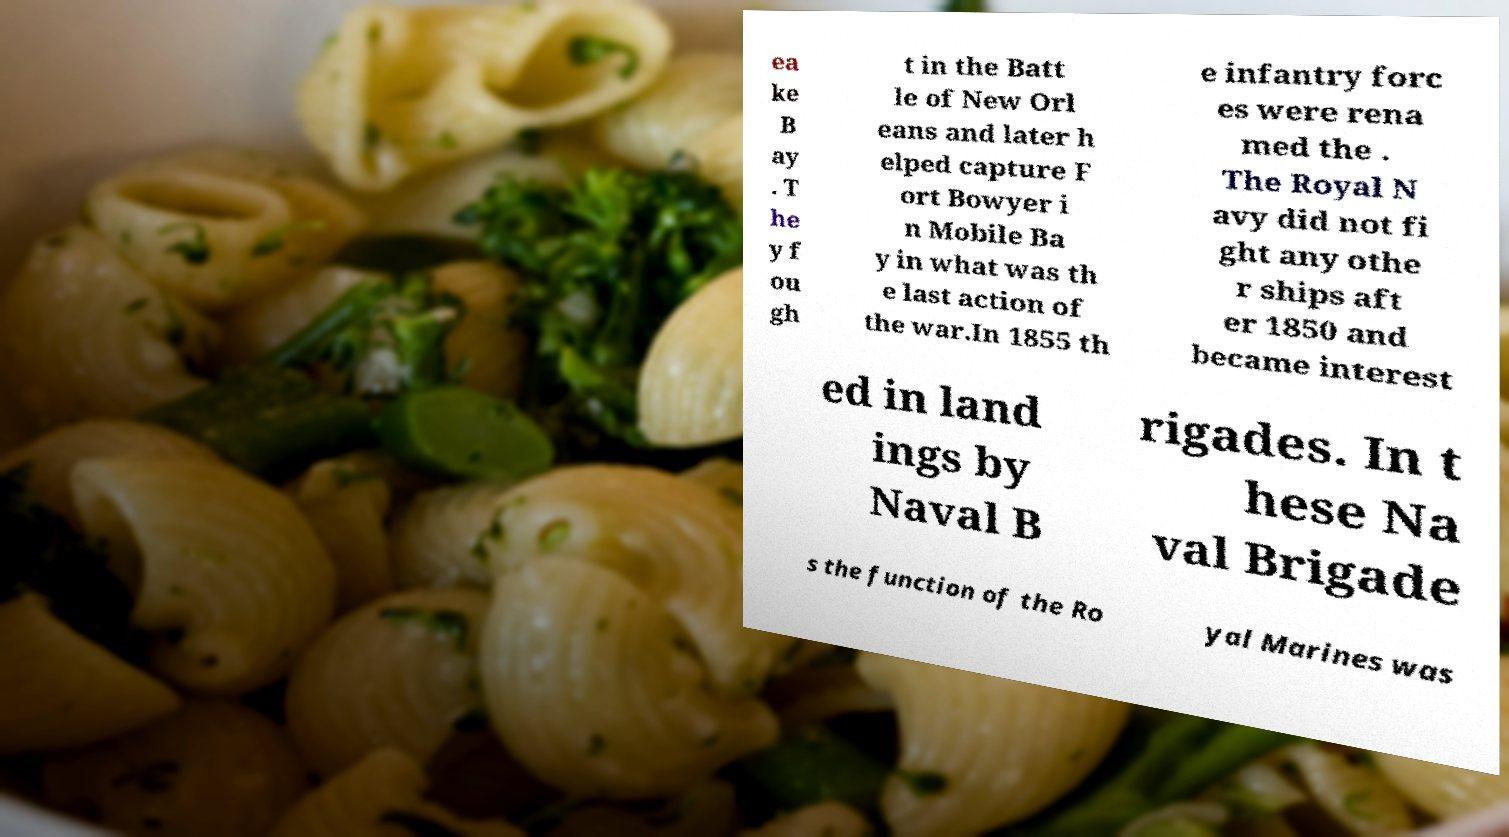There's text embedded in this image that I need extracted. Can you transcribe it verbatim? ea ke B ay . T he y f ou gh t in the Batt le of New Orl eans and later h elped capture F ort Bowyer i n Mobile Ba y in what was th e last action of the war.In 1855 th e infantry forc es were rena med the . The Royal N avy did not fi ght any othe r ships aft er 1850 and became interest ed in land ings by Naval B rigades. In t hese Na val Brigade s the function of the Ro yal Marines was 